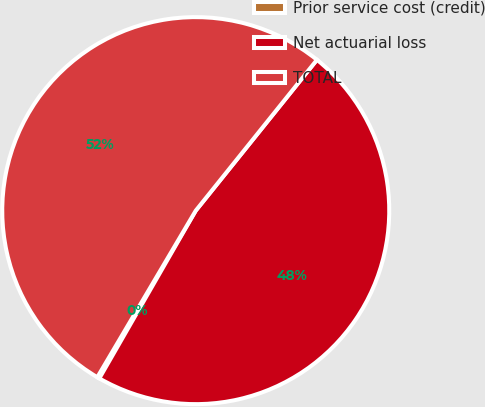Convert chart to OTSL. <chart><loc_0><loc_0><loc_500><loc_500><pie_chart><fcel>Prior service cost (credit)<fcel>Net actuarial loss<fcel>TOTAL<nl><fcel>0.19%<fcel>47.53%<fcel>52.28%<nl></chart> 